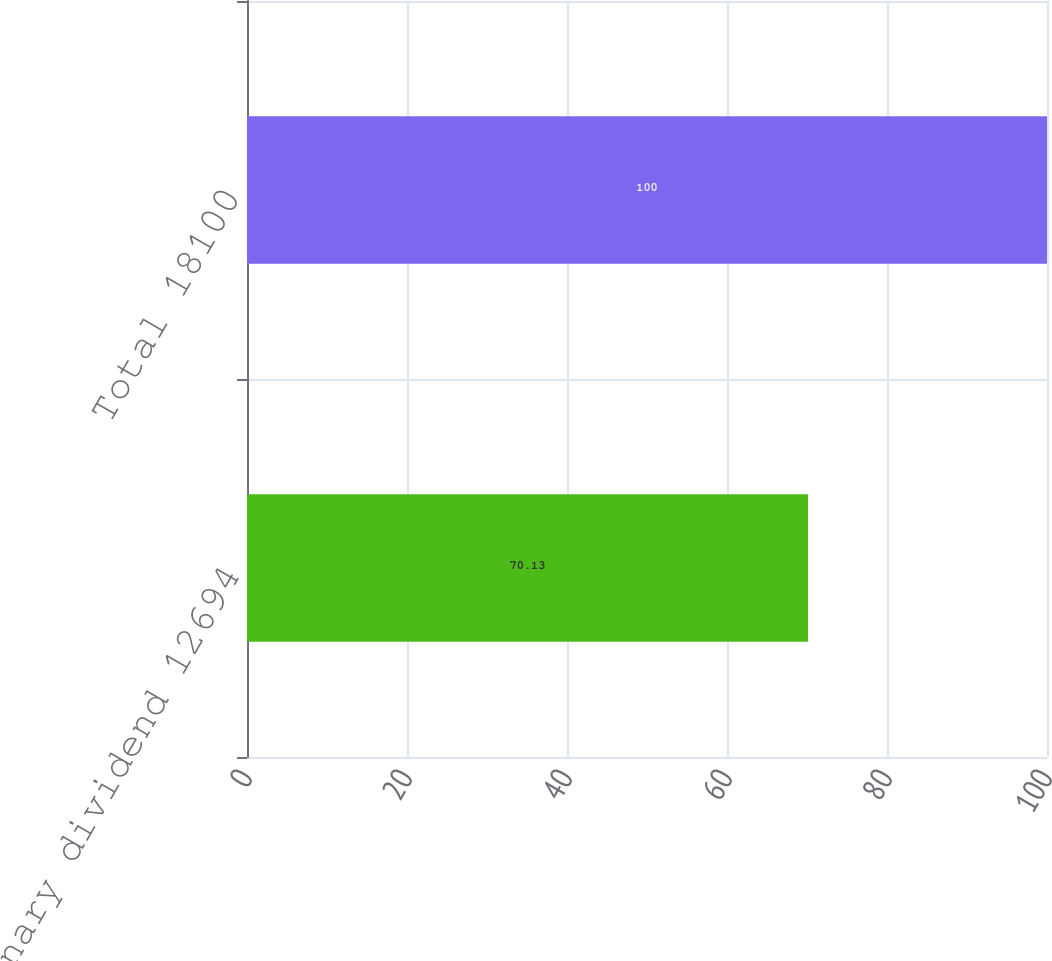Convert chart to OTSL. <chart><loc_0><loc_0><loc_500><loc_500><bar_chart><fcel>Ordinary dividend 12694<fcel>Total 18100<nl><fcel>70.13<fcel>100<nl></chart> 